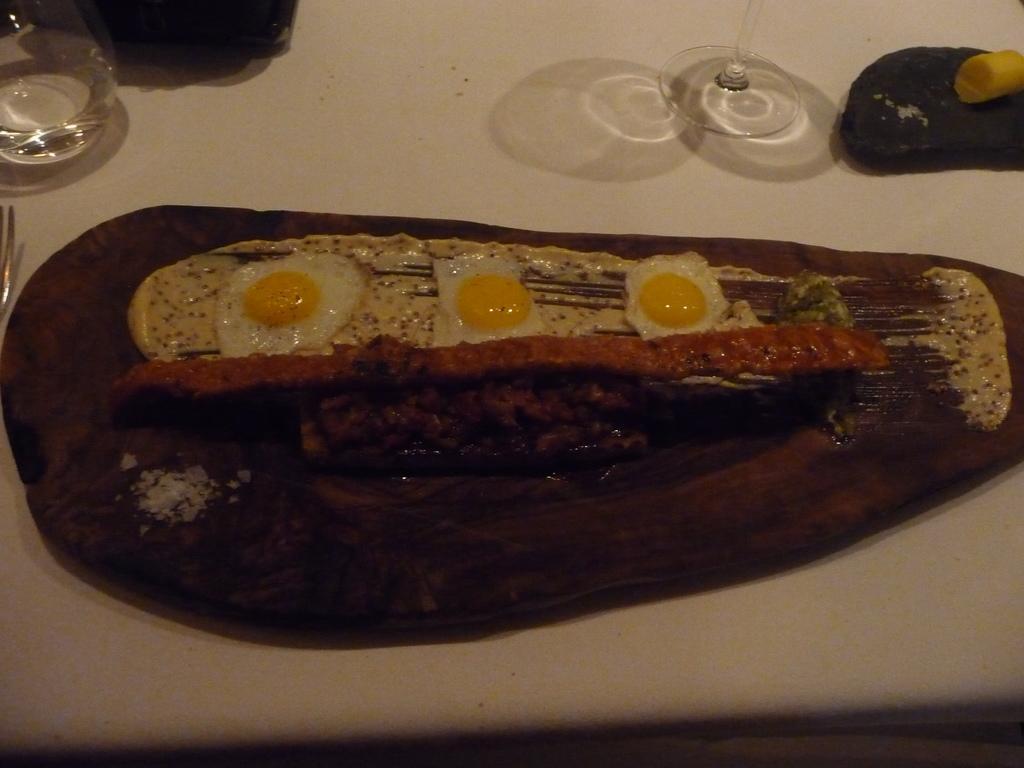Can you describe this image briefly? In this image we can see food items on a wooden surface. There are glasses, spoon on white color table. 